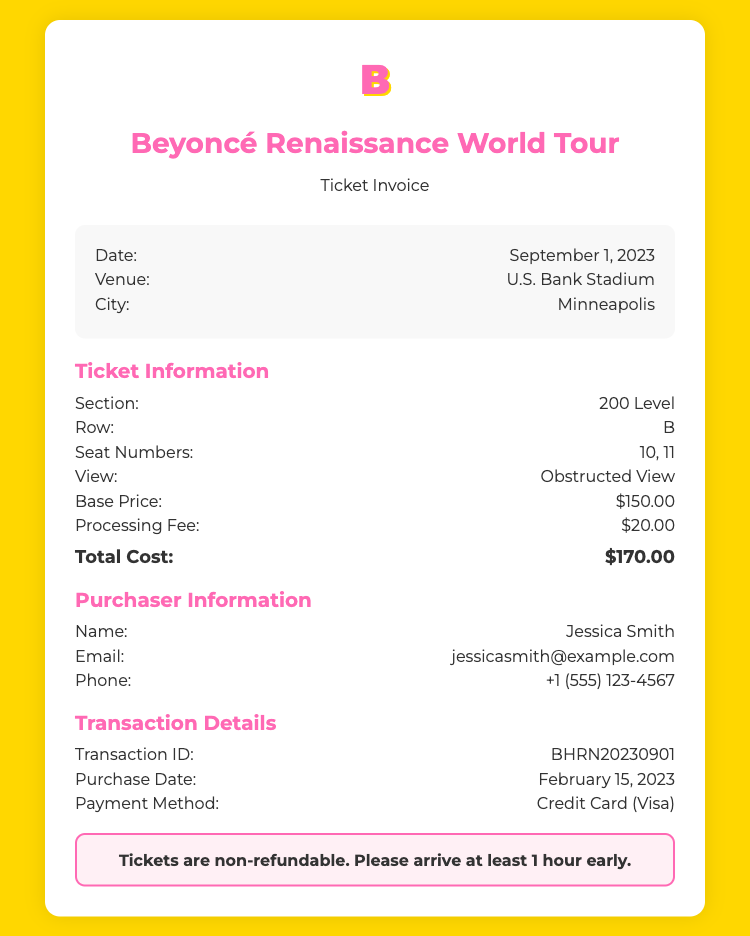what is the date of the concert? The date of the concert is clearly stated in the event details section of the invoice.
Answer: September 1, 2023 where is the concert venue located? The venue is mentioned in the event details, providing specific information about where the concert is held.
Answer: U.S. Bank Stadium what are the seat numbers for this ticket? The seat numbers are specified in the ticket information section of the invoice, detailing the exact locations of the seats.
Answer: 10, 11 what is the processing fee? The processing fee is listed in the ticket information section, providing insight into the additional costs incurred.
Answer: $20.00 what is the total cost of the ticket? The total cost is calculated by summing the base price and processing fee and is highlighted at the end of the ticket information section.
Answer: $170.00 who is the purchaser of the ticket? The name of the purchaser is included in the purchaser information section, identifying the individual who bought the ticket.
Answer: Jessica Smith what was the purchase date of the ticket? The purchase date is specifically mentioned in the transaction details, marking when the ticket was bought.
Answer: February 15, 2023 what payment method was used for the ticket purchase? The payment method is provided in the transaction details, indicating how the ticket was paid for.
Answer: Credit Card (Visa) what type of view does the ticket have? The type of view is outlined in the ticket information section, describing the visibility from the seats.
Answer: Obstructed View 